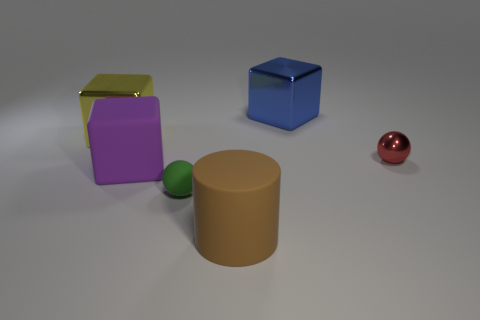What number of things are either small things that are on the left side of the shiny sphere or green spheres?
Your answer should be compact. 1. Does the yellow shiny thing have the same size as the purple block?
Offer a terse response. Yes. There is a tiny thing to the left of the brown matte cylinder; what is its color?
Offer a very short reply. Green. What is the size of the red object that is made of the same material as the blue thing?
Ensure brevity in your answer.  Small. There is a red thing; is it the same size as the block in front of the red metallic ball?
Make the answer very short. No. There is a object on the right side of the blue shiny block; what is its material?
Offer a very short reply. Metal. There is a big matte object that is behind the cylinder; how many yellow metal things are to the right of it?
Your answer should be very brief. 0. Is there a large yellow thing that has the same shape as the purple rubber object?
Provide a short and direct response. Yes. Is the size of the metal cube that is right of the large purple object the same as the sphere that is to the left of the red metallic object?
Give a very brief answer. No. The tiny thing that is in front of the large matte thing left of the tiny green matte ball is what shape?
Offer a terse response. Sphere. 